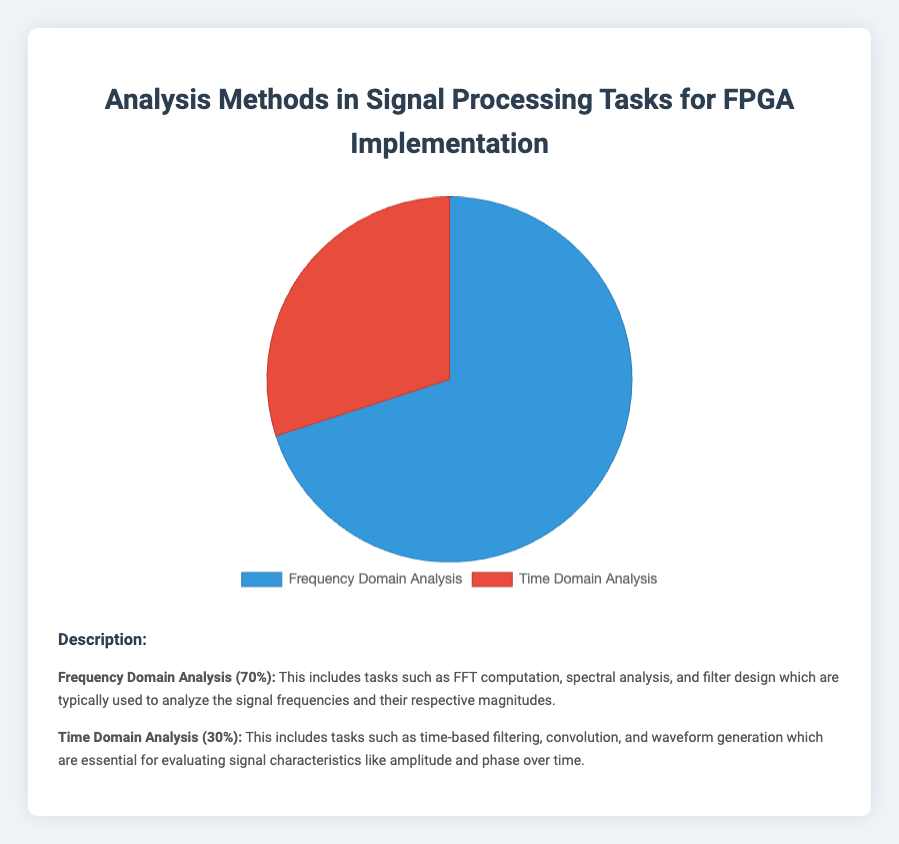What percentage of the tasks are related to Frequency Domain Analysis? From the pie chart, the segment for Frequency Domain Analysis occupies 70% of the chart.
Answer: 70% What percentage of the tasks are related to Time Domain Analysis? The pie chart shows that the segment for Time Domain Analysis occupies 30% of the chart.
Answer: 30% Which analysis method is more prevalent in FPGA implementation tasks, Frequency Domain Analysis or Time Domain Analysis? By comparing the chart segments, we see that Frequency Domain Analysis has a larger segment at 70%, whereas Time Domain Analysis has a smaller segment at 30%. Thus, Frequency Domain Analysis is more prevalent.
Answer: Frequency Domain Analysis How much larger is the percentage of Frequency Domain Analysis tasks compared to Time Domain Analysis tasks? The figure indicates that Frequency Domain Analysis is 70% and Time Domain Analysis is 30%. Subtracting the percentage of Time Domain Analysis from Frequency Domain Analysis gives 70% - 30% = 40%.
Answer: 40% If we were to equally distribute the tasks in these categories, what would the percentage be for each category? Combining both categories' percentages, the sum is 70% + 30% = 100%. Dividing this sum equally across both categories, each category would have 100% / 2 = 50%.
Answer: 50% What is the ratio of Frequency Domain Analysis to Time Domain Analysis tasks? The chart shows 70% for Frequency Domain Analysis and 30% for Time Domain Analysis. The ratio is 70:30, which simplifies to 7:3.
Answer: 7:3 What color represents Time Domain Analysis in the pie chart? The pie chart uses the red segment to represent Time Domain Analysis.
Answer: Red What color represents Frequency Domain Analysis in the pie chart? The pie chart uses the blue segment to represent Frequency Domain Analysis.
Answer: Blue What is the combined percentage for both Frequency Domain Analysis and Time Domain Analysis? The pie chart shows 70% for Frequency Domain Analysis and 30% for Time Domain Analysis. Adding these together gives a combined percentage of 70% + 30% = 100%.
Answer: 100% If an additional 20% of tasks were to be assigned to Time Domain Analysis, what would be the new percentage distribution for both domains? Initially, Frequency Domain Analysis is at 70% and Time Domain Analysis at 30%. Adding 20% to Time Domain Analysis, it becomes 30% + 20% = 50%. Reducing 20% from Frequency Domain Analysis, it becomes 70% - 20% = 50%. Therefore, both domains would have an equal percentage of 50%.
Answer: 50% for each 